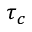<formula> <loc_0><loc_0><loc_500><loc_500>\tau _ { c }</formula> 